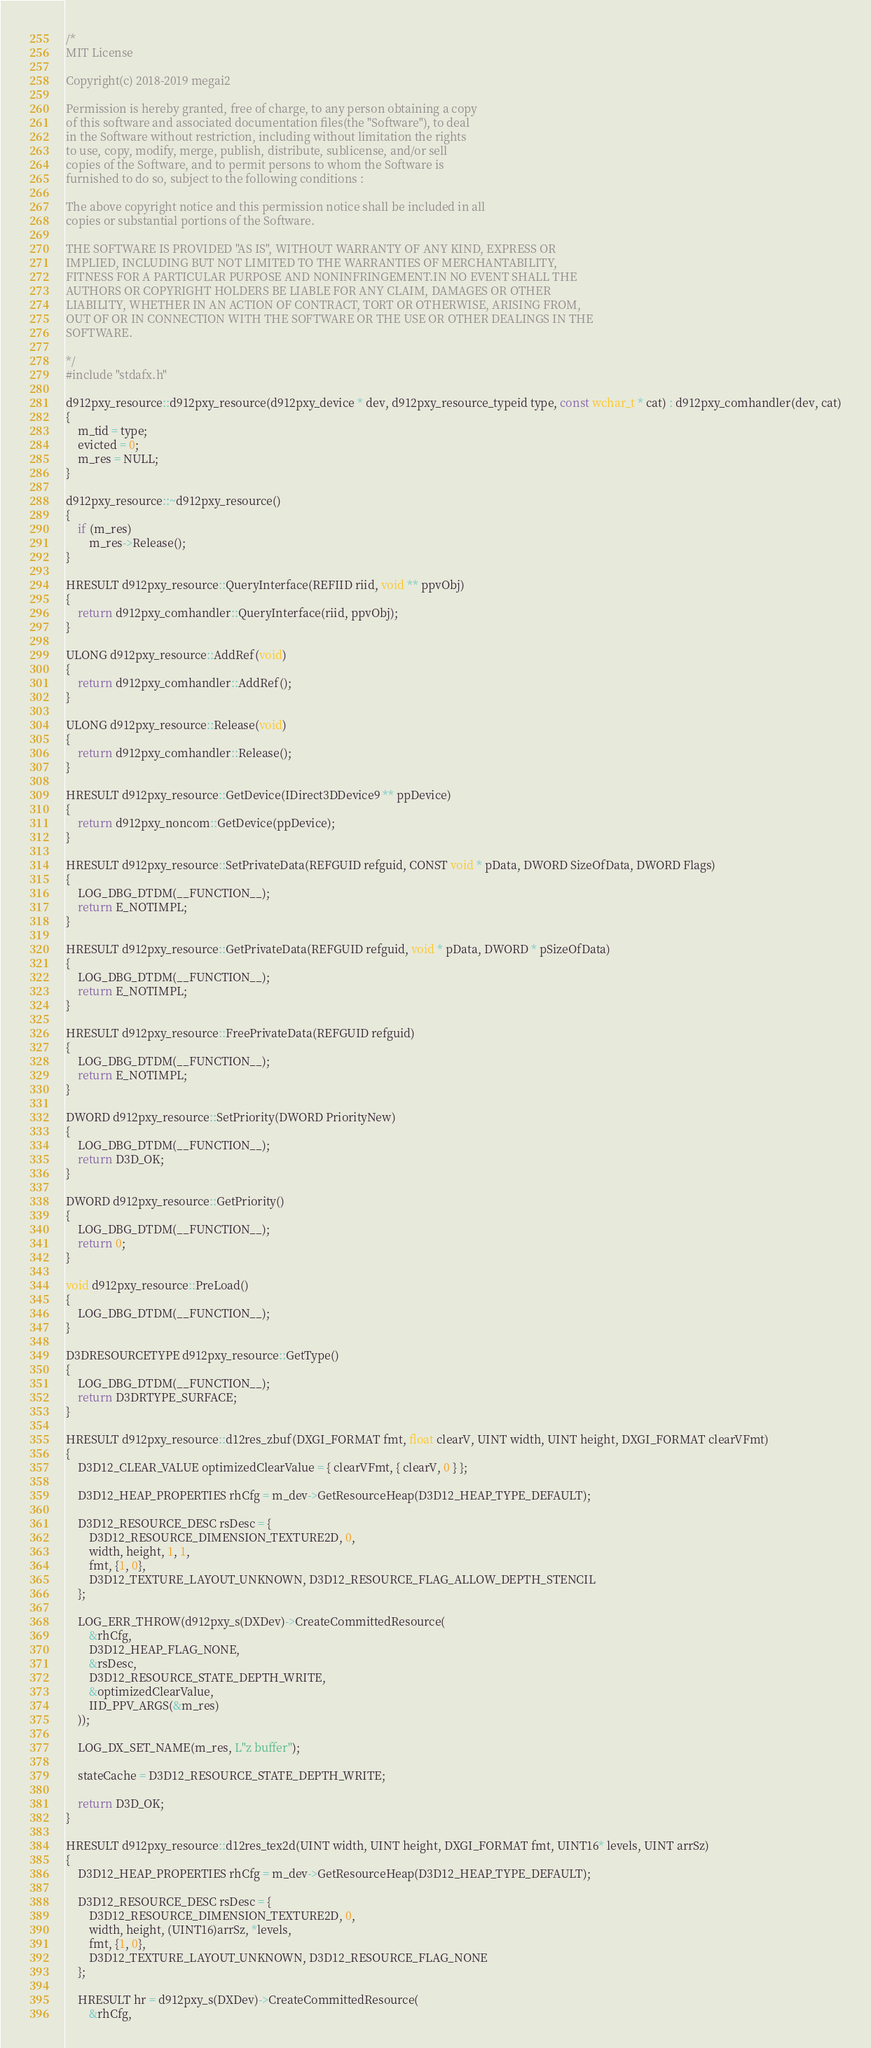Convert code to text. <code><loc_0><loc_0><loc_500><loc_500><_C++_>/*
MIT License

Copyright(c) 2018-2019 megai2

Permission is hereby granted, free of charge, to any person obtaining a copy
of this software and associated documentation files(the "Software"), to deal
in the Software without restriction, including without limitation the rights
to use, copy, modify, merge, publish, distribute, sublicense, and/or sell
copies of the Software, and to permit persons to whom the Software is
furnished to do so, subject to the following conditions :

The above copyright notice and this permission notice shall be included in all
copies or substantial portions of the Software.

THE SOFTWARE IS PROVIDED "AS IS", WITHOUT WARRANTY OF ANY KIND, EXPRESS OR
IMPLIED, INCLUDING BUT NOT LIMITED TO THE WARRANTIES OF MERCHANTABILITY,
FITNESS FOR A PARTICULAR PURPOSE AND NONINFRINGEMENT.IN NO EVENT SHALL THE
AUTHORS OR COPYRIGHT HOLDERS BE LIABLE FOR ANY CLAIM, DAMAGES OR OTHER
LIABILITY, WHETHER IN AN ACTION OF CONTRACT, TORT OR OTHERWISE, ARISING FROM,
OUT OF OR IN CONNECTION WITH THE SOFTWARE OR THE USE OR OTHER DEALINGS IN THE
SOFTWARE.

*/
#include "stdafx.h"

d912pxy_resource::d912pxy_resource(d912pxy_device * dev, d912pxy_resource_typeid type, const wchar_t * cat) : d912pxy_comhandler(dev, cat)
{
	m_tid = type;	
	evicted = 0;
	m_res = NULL;
}

d912pxy_resource::~d912pxy_resource()
{
	if (m_res)
		m_res->Release();
}

HRESULT d912pxy_resource::QueryInterface(REFIID riid, void ** ppvObj)
{
	return d912pxy_comhandler::QueryInterface(riid, ppvObj);
}

ULONG d912pxy_resource::AddRef(void)
{
	return d912pxy_comhandler::AddRef();
}

ULONG d912pxy_resource::Release(void)
{
	return d912pxy_comhandler::Release();
}

HRESULT d912pxy_resource::GetDevice(IDirect3DDevice9 ** ppDevice)
{
	return d912pxy_noncom::GetDevice(ppDevice);
}

HRESULT d912pxy_resource::SetPrivateData(REFGUID refguid, CONST void * pData, DWORD SizeOfData, DWORD Flags)
{
	LOG_DBG_DTDM(__FUNCTION__);
	return E_NOTIMPL;
}

HRESULT d912pxy_resource::GetPrivateData(REFGUID refguid, void * pData, DWORD * pSizeOfData)
{
	LOG_DBG_DTDM(__FUNCTION__);
	return E_NOTIMPL;
}

HRESULT d912pxy_resource::FreePrivateData(REFGUID refguid)
{
	LOG_DBG_DTDM(__FUNCTION__);
	return E_NOTIMPL;
}

DWORD d912pxy_resource::SetPriority(DWORD PriorityNew)
{
	LOG_DBG_DTDM(__FUNCTION__);
	return D3D_OK;
}

DWORD d912pxy_resource::GetPriority()
{
	LOG_DBG_DTDM(__FUNCTION__);
	return 0;
}

void d912pxy_resource::PreLoad()
{
	LOG_DBG_DTDM(__FUNCTION__);
}

D3DRESOURCETYPE d912pxy_resource::GetType()
{
	LOG_DBG_DTDM(__FUNCTION__);
	return D3DRTYPE_SURFACE;
}

HRESULT d912pxy_resource::d12res_zbuf(DXGI_FORMAT fmt, float clearV, UINT width, UINT height, DXGI_FORMAT clearVFmt)
{
	D3D12_CLEAR_VALUE optimizedClearValue = { clearVFmt, { clearV, 0 } };

	D3D12_HEAP_PROPERTIES rhCfg = m_dev->GetResourceHeap(D3D12_HEAP_TYPE_DEFAULT);

	D3D12_RESOURCE_DESC rsDesc = { 
		D3D12_RESOURCE_DIMENSION_TEXTURE2D, 0, 
		width, height, 1, 1, 
		fmt, {1, 0}, 
		D3D12_TEXTURE_LAYOUT_UNKNOWN, D3D12_RESOURCE_FLAG_ALLOW_DEPTH_STENCIL 
	};
	
	LOG_ERR_THROW(d912pxy_s(DXDev)->CreateCommittedResource(
		&rhCfg,
		D3D12_HEAP_FLAG_NONE,
		&rsDesc,
		D3D12_RESOURCE_STATE_DEPTH_WRITE,
		&optimizedClearValue,
		IID_PPV_ARGS(&m_res)
	));

	LOG_DX_SET_NAME(m_res, L"z buffer");

	stateCache = D3D12_RESOURCE_STATE_DEPTH_WRITE;

	return D3D_OK;
}

HRESULT d912pxy_resource::d12res_tex2d(UINT width, UINT height, DXGI_FORMAT fmt, UINT16* levels, UINT arrSz)
{
	D3D12_HEAP_PROPERTIES rhCfg = m_dev->GetResourceHeap(D3D12_HEAP_TYPE_DEFAULT);
	
	D3D12_RESOURCE_DESC rsDesc = {
		D3D12_RESOURCE_DIMENSION_TEXTURE2D, 0,
		width, height, (UINT16)arrSz, *levels,
		fmt, {1, 0},
		D3D12_TEXTURE_LAYOUT_UNKNOWN, D3D12_RESOURCE_FLAG_NONE
	};

	HRESULT hr = d912pxy_s(DXDev)->CreateCommittedResource(
		&rhCfg,</code> 